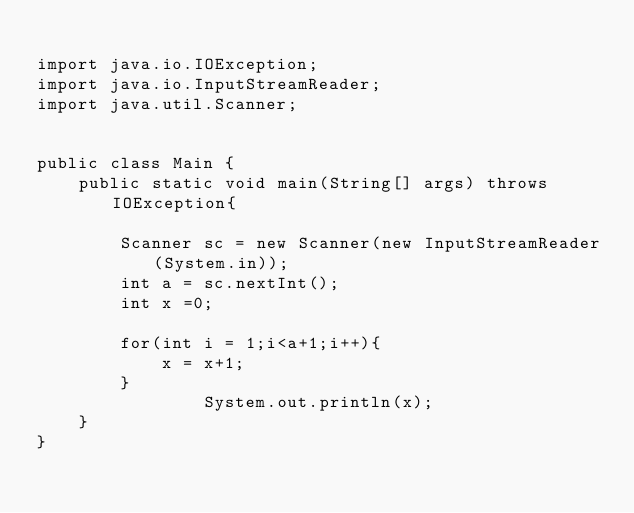<code> <loc_0><loc_0><loc_500><loc_500><_Java_>
import java.io.IOException;
import java.io.InputStreamReader;
import java.util.Scanner;


public class Main {
	public static void main(String[] args) throws IOException{

		Scanner sc = new Scanner(new InputStreamReader(System.in));
		int a = sc.nextInt();
		int x =0;
		
		for(int i = 1;i<a+1;i++){
			x = x+1;
		}
                System.out.println(x);
	}
}
</code> 